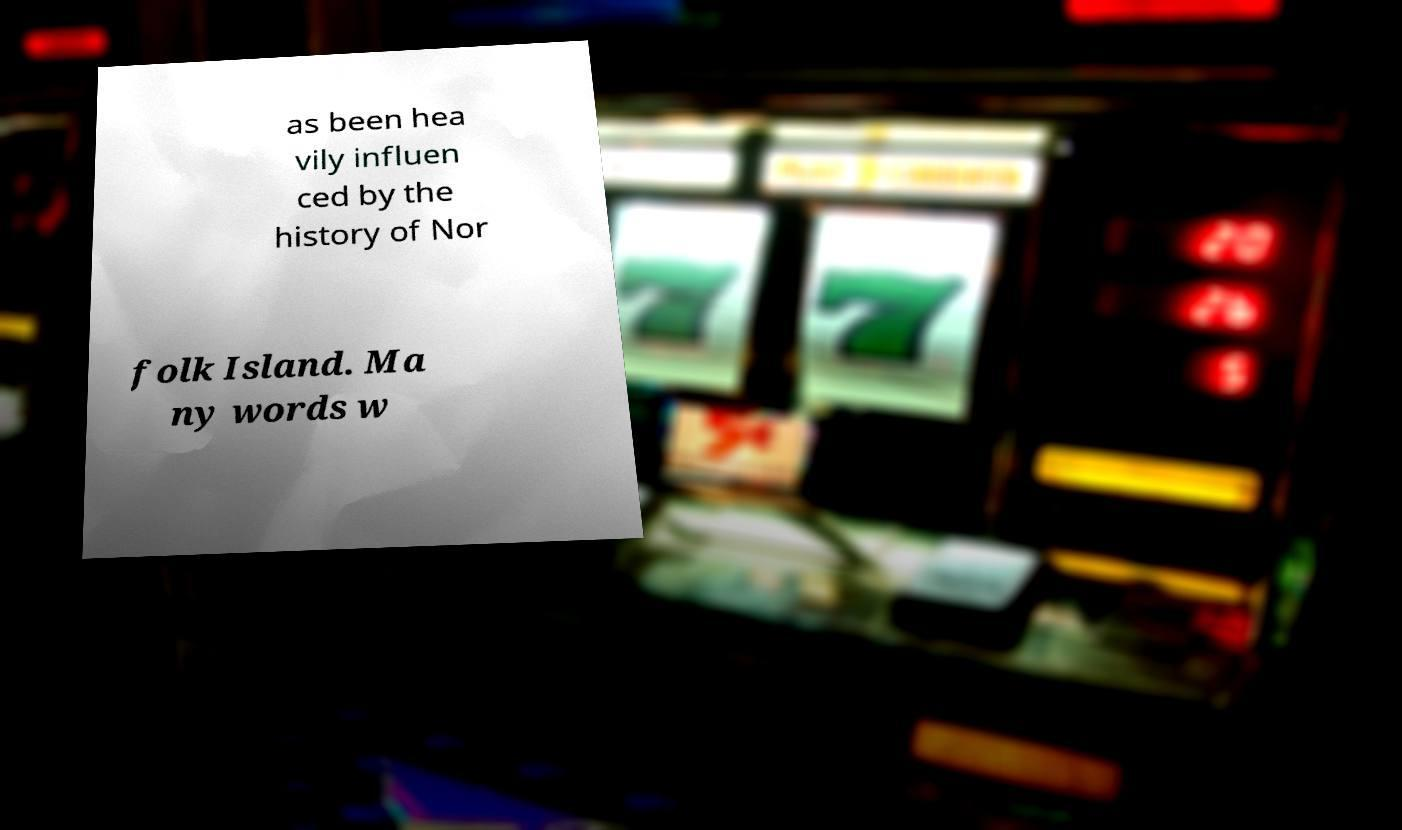What messages or text are displayed in this image? I need them in a readable, typed format. as been hea vily influen ced by the history of Nor folk Island. Ma ny words w 